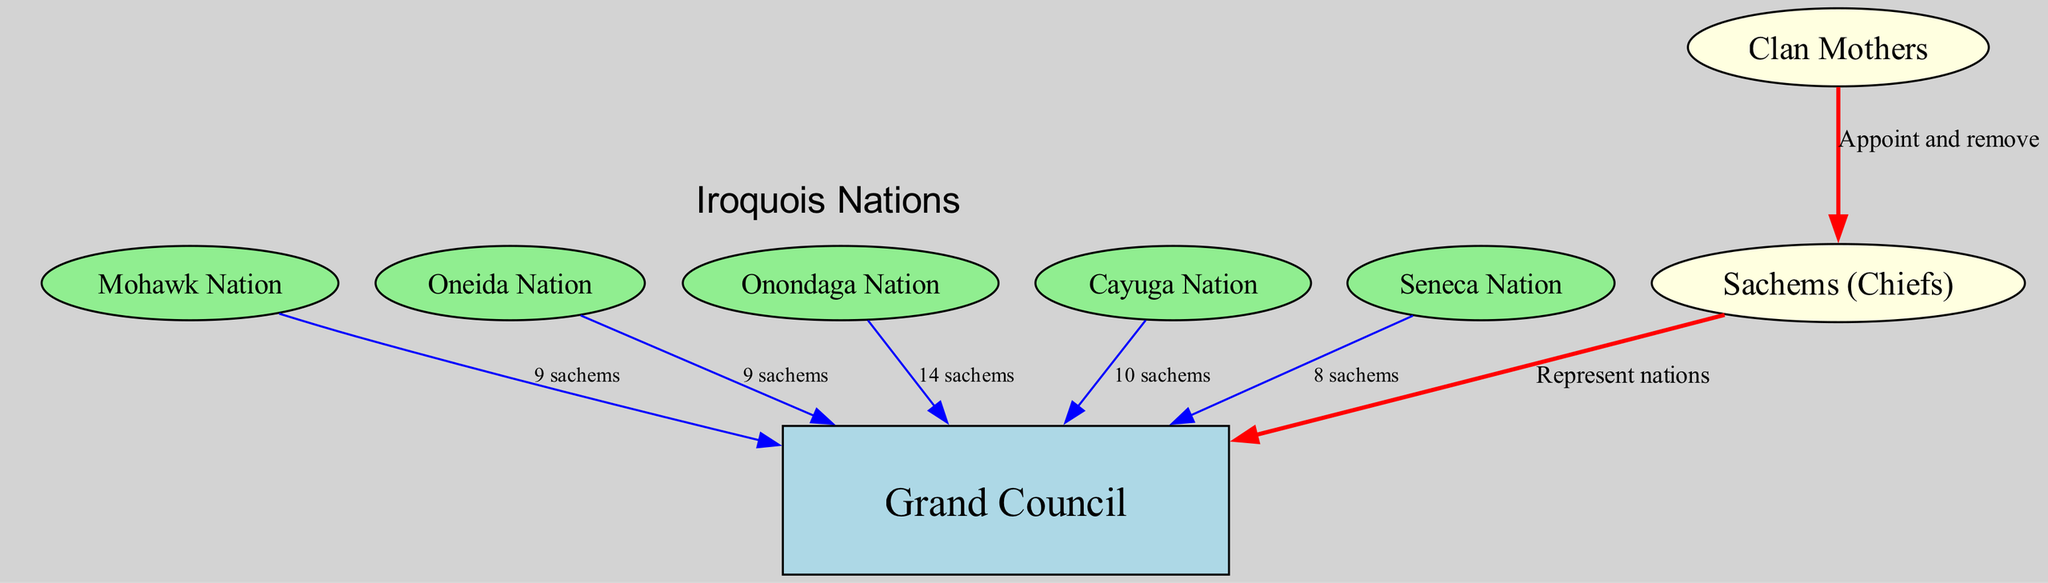What is the total number of nations in the Iroquois Confederacy? The nodes list includes five nations: Mohawk, Oneida, Onondaga, Cayuga, and Seneca. By counting these nodes, we find the total.
Answer: 5 How many sachems come from the Onondaga Nation? The diagram indicates that the Onondaga Nation contributes 14 sachems as denoted in the edge from Onondaga to the Grand Council.
Answer: 14 What is the role of Clan Mothers in this structure? According to the edge connecting Clan Mothers to Chiefs, their role involves appointing and removing the Chiefs. This explicitly states their function.
Answer: Appoint and remove Which nation has the least representation in the Grand Council? By examining the edges leading to the Grand Council, we see that the Seneca Nation contributes only 8 sachems, which is the lowest among all nations in this diagram.
Answer: 8 sachems Who do the Chiefs represent in the decision-making process? The edge from Chiefs to Grand Council indicates that Chiefs represent the nations in the Grand Council. This establishes their direct involvement in the political structure.
Answer: Nations What color represents the Grand Council in the diagram? The Grand Council is shown in a light blue rectangle, which is distinct from other nodes in the diagram. The color categorization helps identify its importance.
Answer: Light blue How many sachems are contributed by the Mohawk Nation? The diagram specifies that the Mohawk Nation sends 9 sachems to the Grand Council, as shown on the connection from Mohawk to Grand Council.
Answer: 9 sachems What is the main connection link between Clan Mothers and Chiefs? The relationship outlined in the diagram shows that Clan Mothers appoint and remove Chiefs, which indicates their authority and critical role in the leadership process.
Answer: Appoint and remove Which nation contributes the most sachems to the Grand Council? Upon review of the edges leading to the Grand Council, the Onondaga Nation, with 14 sachems, has the highest contribution, surpassing the rest.
Answer: 14 sachems 